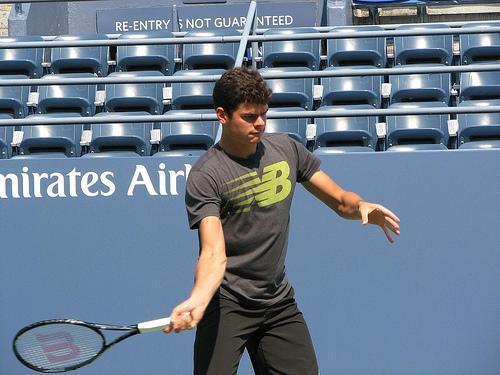How many people?
Give a very brief answer. 1. 